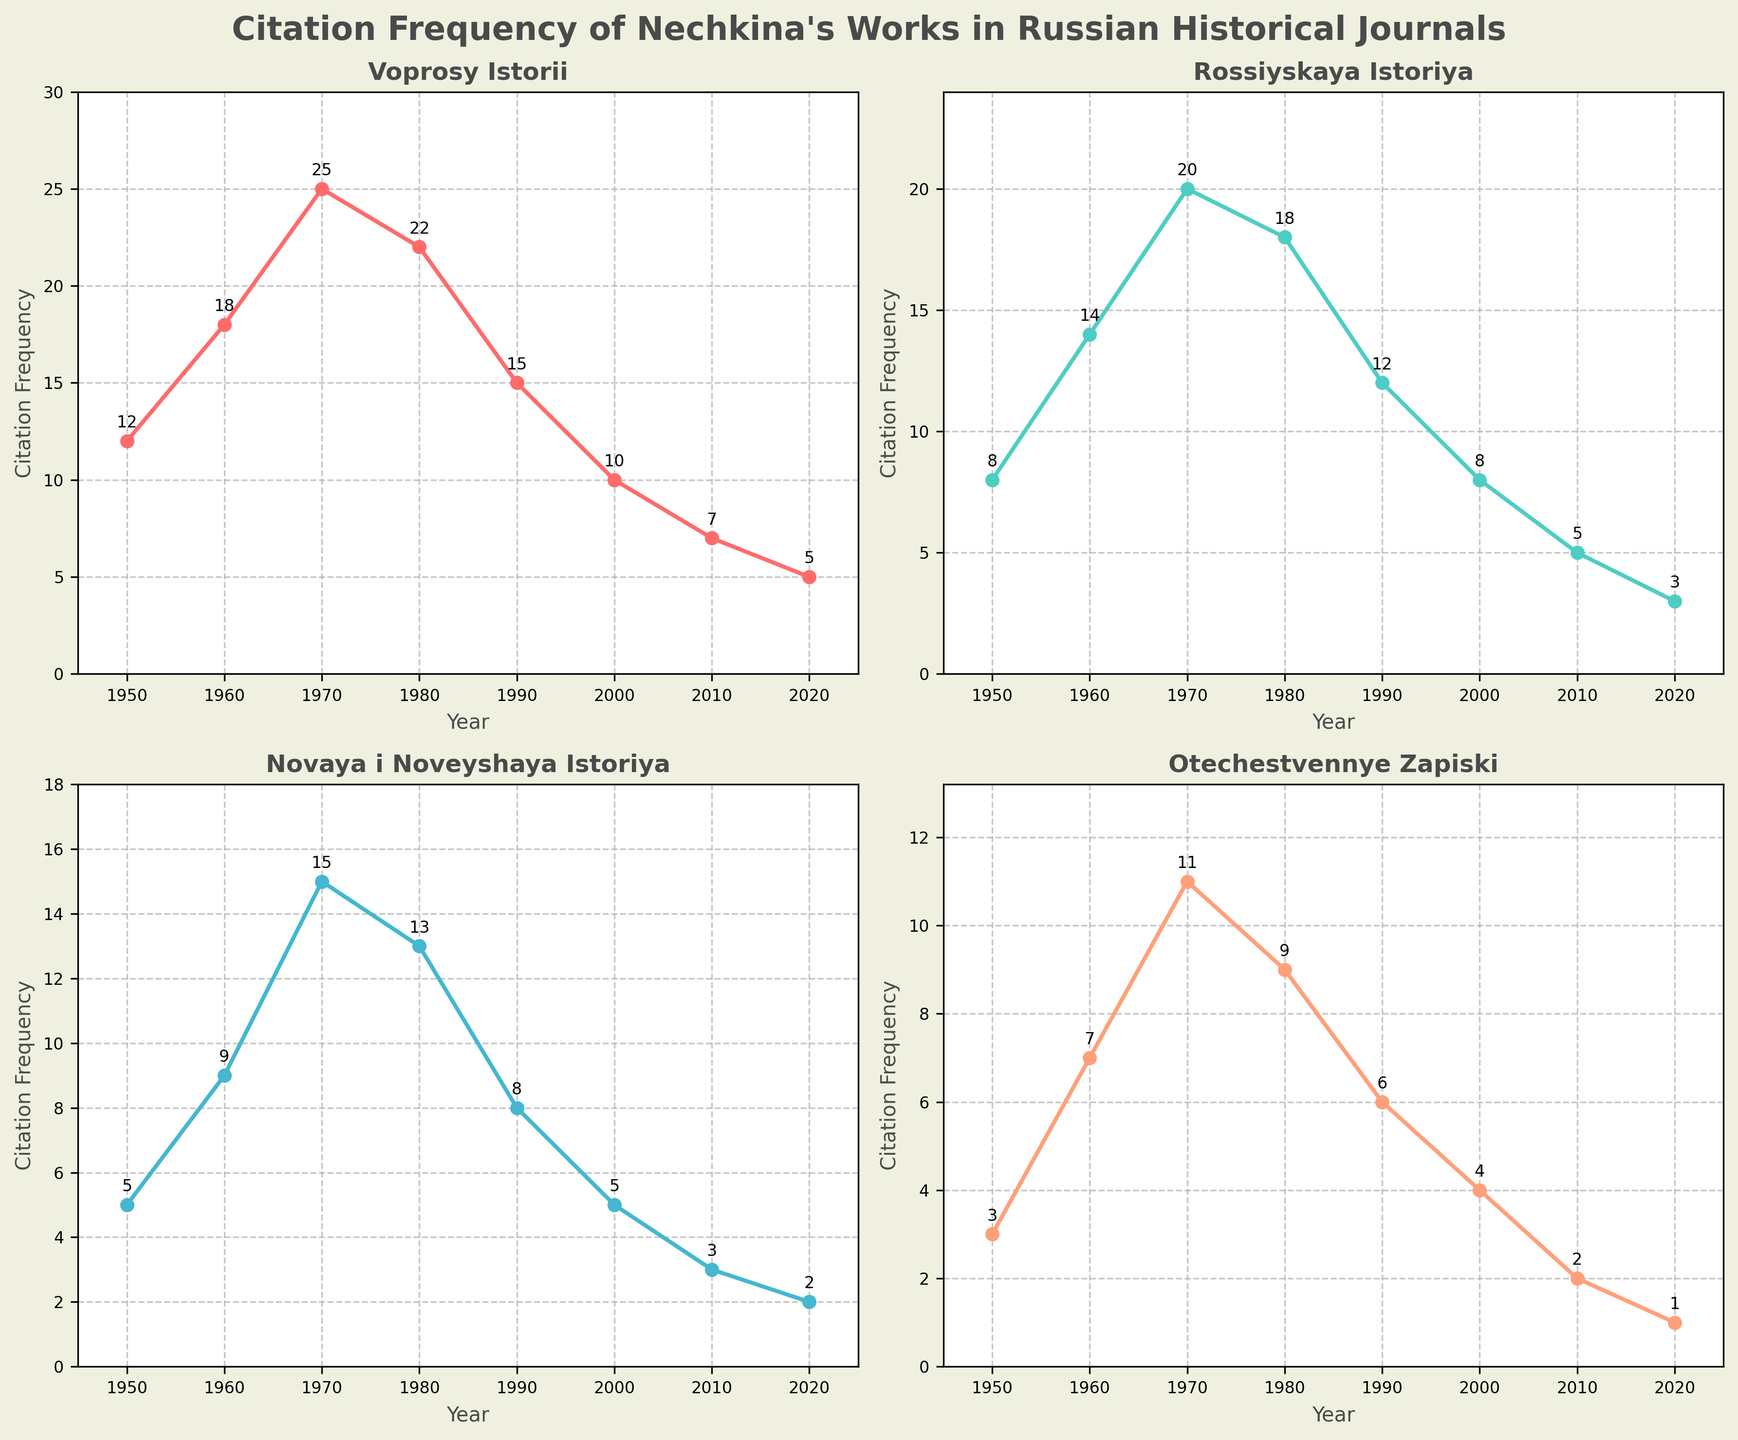What is the title of the plot? The title is displayed at the top of the figure in bold letters. It reads, "Citation Frequency of Nechkina's Works in Russian Historical Journals"
Answer: Citation Frequency of Nechkina's Works in Russian Historical Journals Which journal had the highest citation frequency in 1970? By looking at the subplots, the highest point in 1970 can be seen in the subplot for "Voprosy Istorii" where it reaches 25 citations
Answer: Voprosy Istorii How many citation frequencies are there for each journal? Each subplot represents one journal, where there are 8 data points (years: 1950, 1960, 1970, 1980, 1990, 2000, 2010, 2020) shown with markers
Answer: 8 Which year had the overall lowest citation frequency for "Otechestvennye Zapiski"? In the "Otechestvennye Zapiski" subplot, the lowest value can be seen in 2020 with 1 citation
Answer: 2020 What trend is observed in the citation frequency of "Rossiyskaya Istoriya" from 1950 to 2020? The trend can be observed by following the line from 1950 to 2020 in the "Rossiyskaya Istoriya" subplot. It generally decreases over time from 14 citations in 1960 to 3 citations in 2020
Answer: Decreasing trend What is the difference in citation frequency between 1980 and 2000 for "Novaya i Noveyshaya Istoriya"? For "Novaya i Noveyshaya Istoriya," the citation frequency in 1980 is 13, and in 2000 it is 5. The difference is calculated as 13 - 5 = 8
Answer: 8 Which journal had at least 10 citations at some point in every listed year? By looking at each subplot and identifying the minimum frequency, "Voprosy Istorii" consistently has citations above 10 in all listed years
Answer: Voprosy Istorii In which year did "Voprosy Istorii" see its peak citation frequency? The peak can be identified in the "Voprosy Istorii" subplot where the citations are highest at 25 in 1970
Answer: 1970 Which journal has shown the steepest decline in citation frequency from 1980 to 2020? Comparing the slopes from 1980 to 2020 for each journal, "Novaya i Noveyshaya Istoriya" declined from 13 to 2, which is the steepest drop among all
Answer: Novaya i Noveyshaya Istoriya How does the citation frequency of "Otechestvennye Zapiski" in 2000 compare to "Novaya i Noveyshaya Istoriya" in 2010? In 2000, "Otechestvennye Zapiski" has 4 citations, while in 2010 "Novaya i Noveyshaya Istoriya" has 3 citations. 4 is greater than 3
Answer: Otechestvennye Zapiski has higher citations in 2000 than Novaya i Noveyshaya Istoriya in 2010 